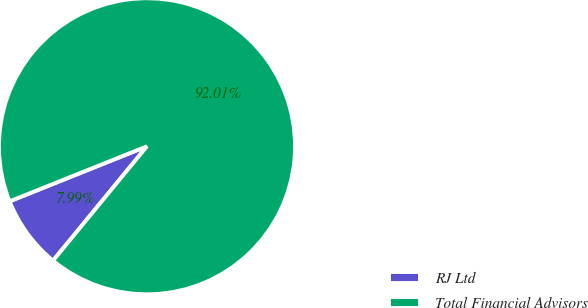Convert chart to OTSL. <chart><loc_0><loc_0><loc_500><loc_500><pie_chart><fcel>RJ Ltd<fcel>Total Financial Advisors<nl><fcel>7.99%<fcel>92.01%<nl></chart> 